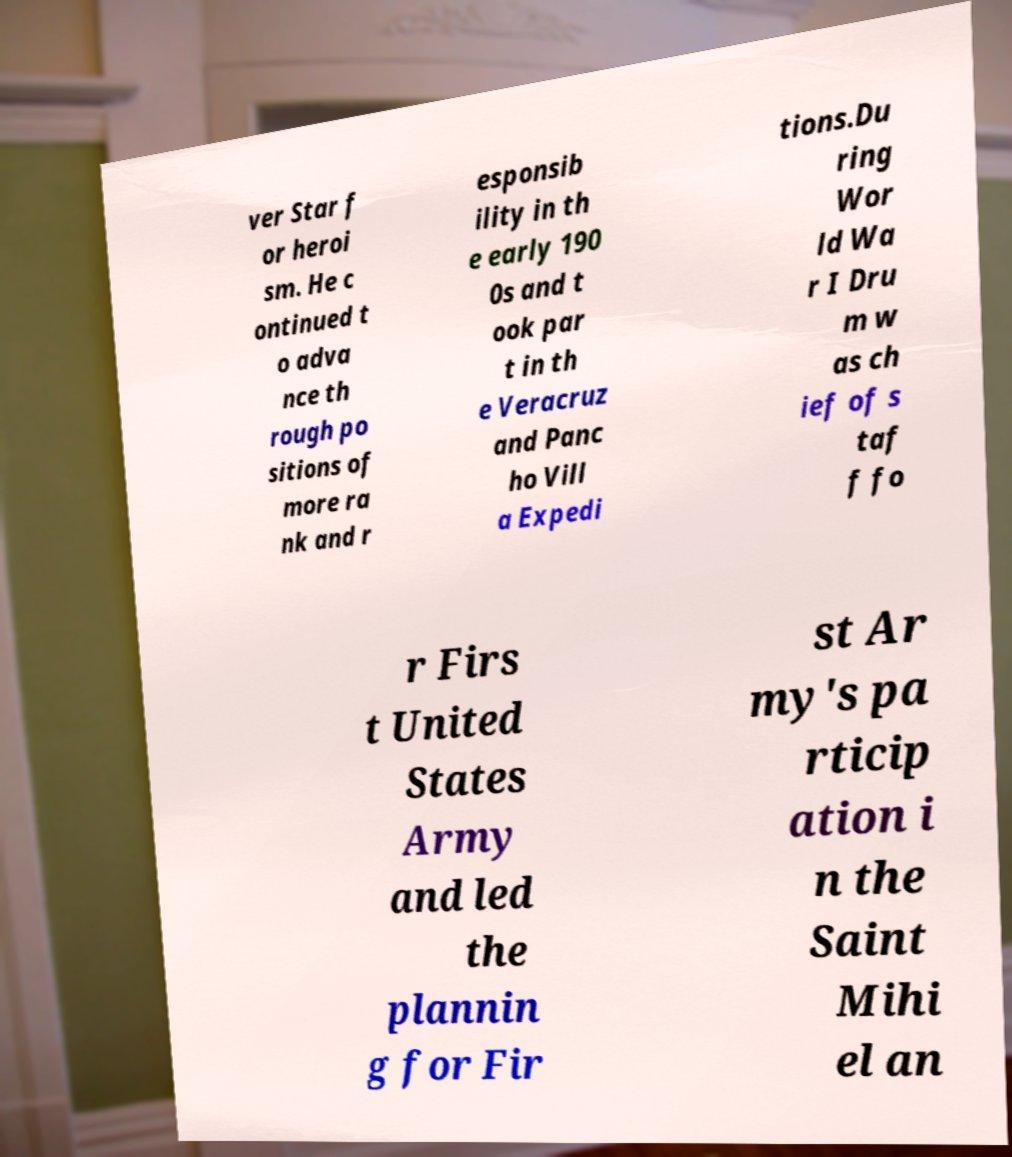Could you assist in decoding the text presented in this image and type it out clearly? ver Star f or heroi sm. He c ontinued t o adva nce th rough po sitions of more ra nk and r esponsib ility in th e early 190 0s and t ook par t in th e Veracruz and Panc ho Vill a Expedi tions.Du ring Wor ld Wa r I Dru m w as ch ief of s taf f fo r Firs t United States Army and led the plannin g for Fir st Ar my's pa rticip ation i n the Saint Mihi el an 